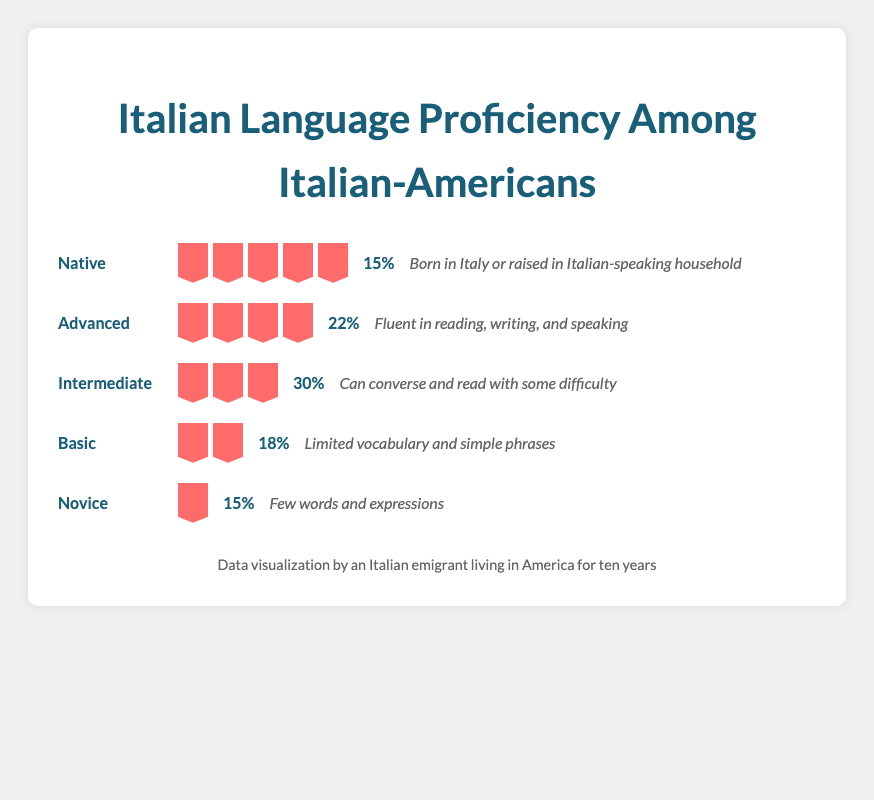What is the percentage of Italian-Americans with Intermediate language proficiency? The figure shows the percentage of Italian-Americans with different proficiency levels. The row labeled "Intermediate" shows a percentage value.
Answer: 30% How many books are used to represent the Advanced proficiency level? The figure uses books as icons to represent proficiency levels. Count the number of book icons in the row labeled "Advanced."
Answer: 4 Which proficiency levels have the same percentage of Italian-Americans? Look at the percentage values in the figure and identify any that are the same. Both "Native" and "Novice" levels show the same percentage value.
Answer: Native and Novice What is the difference in percentages between the Intermediate and Basic proficiency levels? Subtract the percentage of Basic proficiency (18%) from Intermediate proficiency (30%).
Answer: 12% How many proficiency levels have two or more books? Count the number of rows where the number of book icons is two or more.
Answer: 4 Which proficiency level has the highest percentage of Italian-Americans? Identify the highest percentage value in the figure. The Intermediate level has 30%.
Answer: Intermediate How many books are used in total to represent all proficiency levels? Add up the number of book icons across all rows. Native has 5, Advanced has 4, Intermediate has 3, Basic has 2, and Novice has 1. Summing these gives 5 + 4 + 3 + 2 + 1.
Answer: 15 What is the average percentage of Italian-Americans across all proficiency levels? Add up the percentages of all proficiency levels and divide by the number of levels (5). (15 + 22 + 30 + 18 + 15) / 5.
Answer: 20% Which category describes people born in Italy or raised in an Italian-speaking household? Look at the descriptions in the figure. The "Native" proficiency level has this description.
Answer: Native What percentage of Italian-Americans have either Basic or Novice proficiency levels? Add the percentage values for Basic (18%) and Novice (15%).
Answer: 33% 